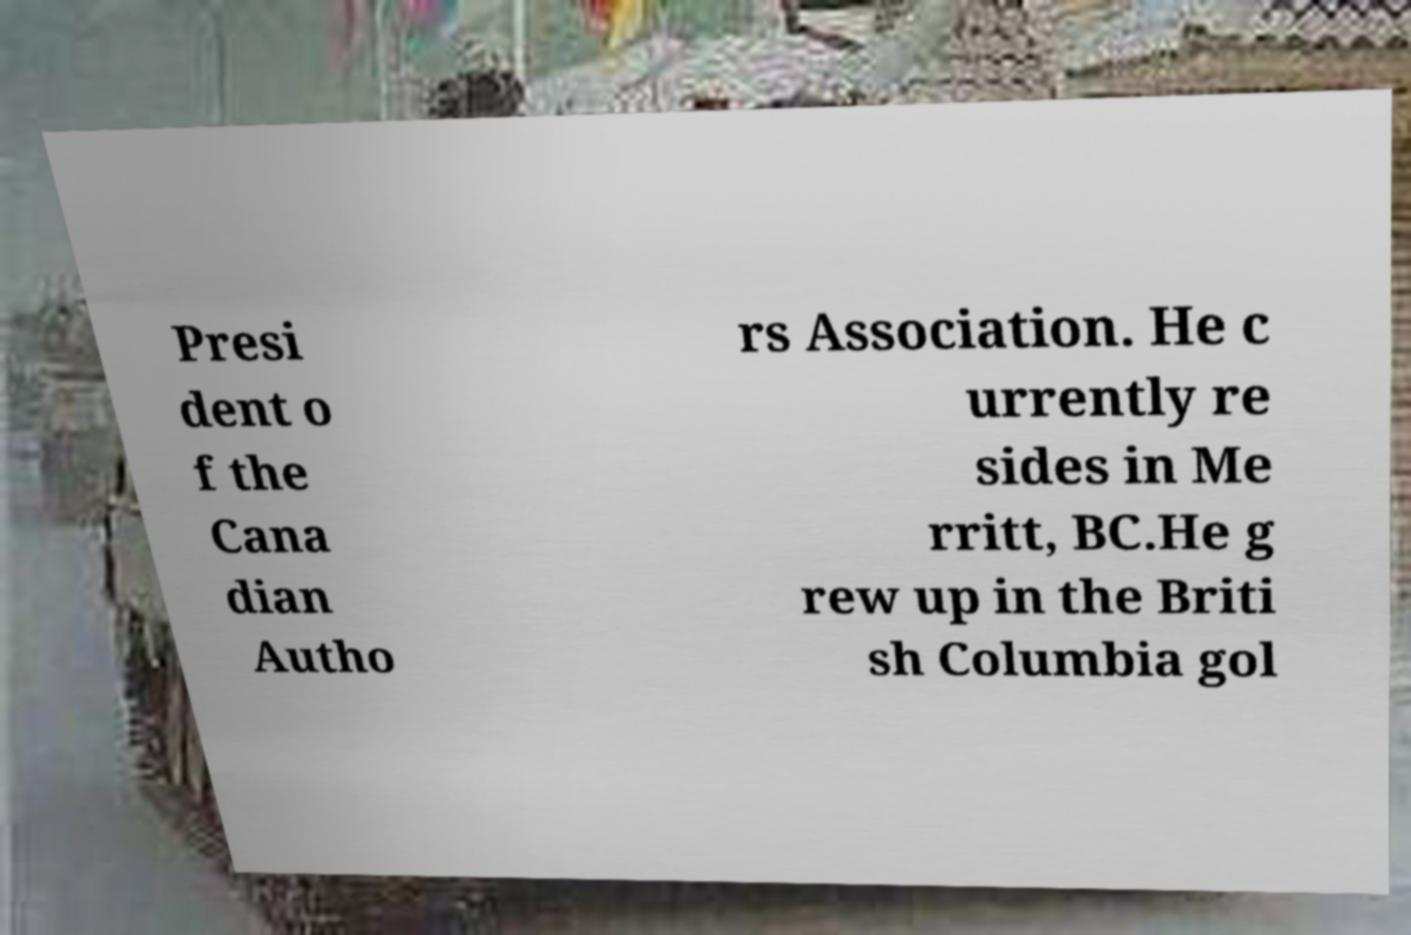Could you assist in decoding the text presented in this image and type it out clearly? Presi dent o f the Cana dian Autho rs Association. He c urrently re sides in Me rritt, BC.He g rew up in the Briti sh Columbia gol 